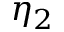Convert formula to latex. <formula><loc_0><loc_0><loc_500><loc_500>\eta _ { 2 }</formula> 